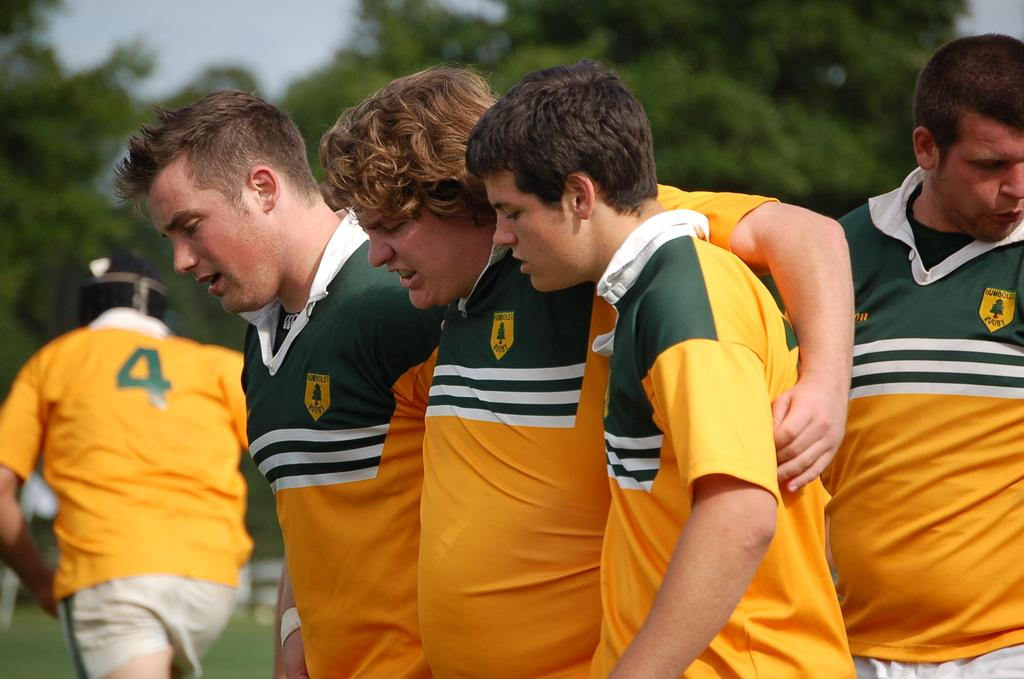<image>
Relay a brief, clear account of the picture shown. a player has the number 4 on their backs outside 